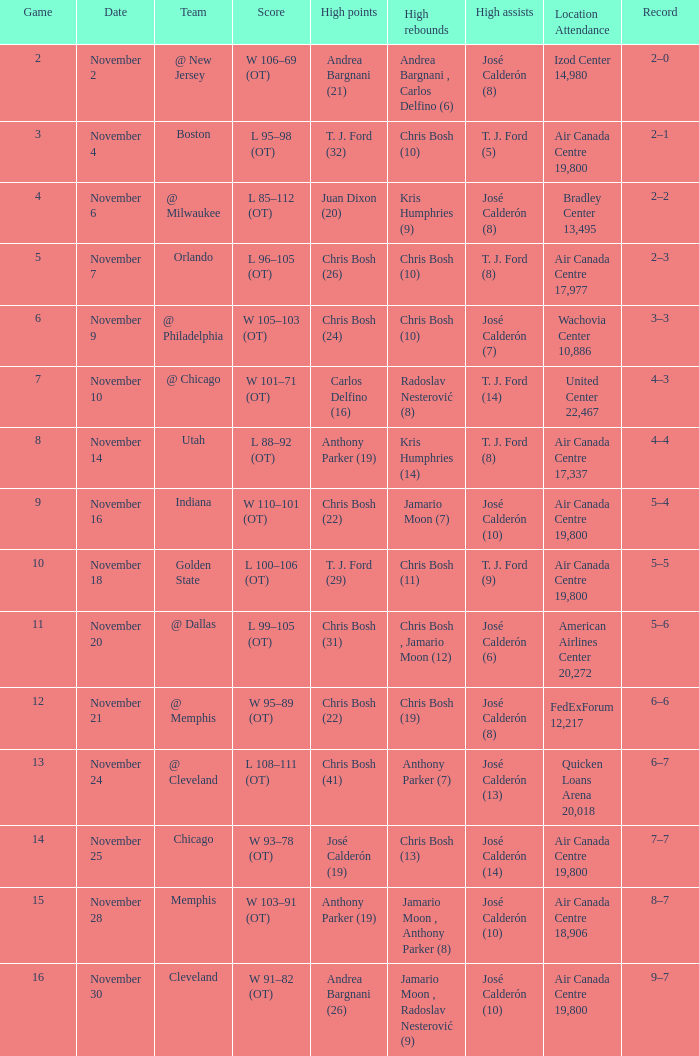What is the score when the team is playing at cleveland? L 108–111 (OT). 